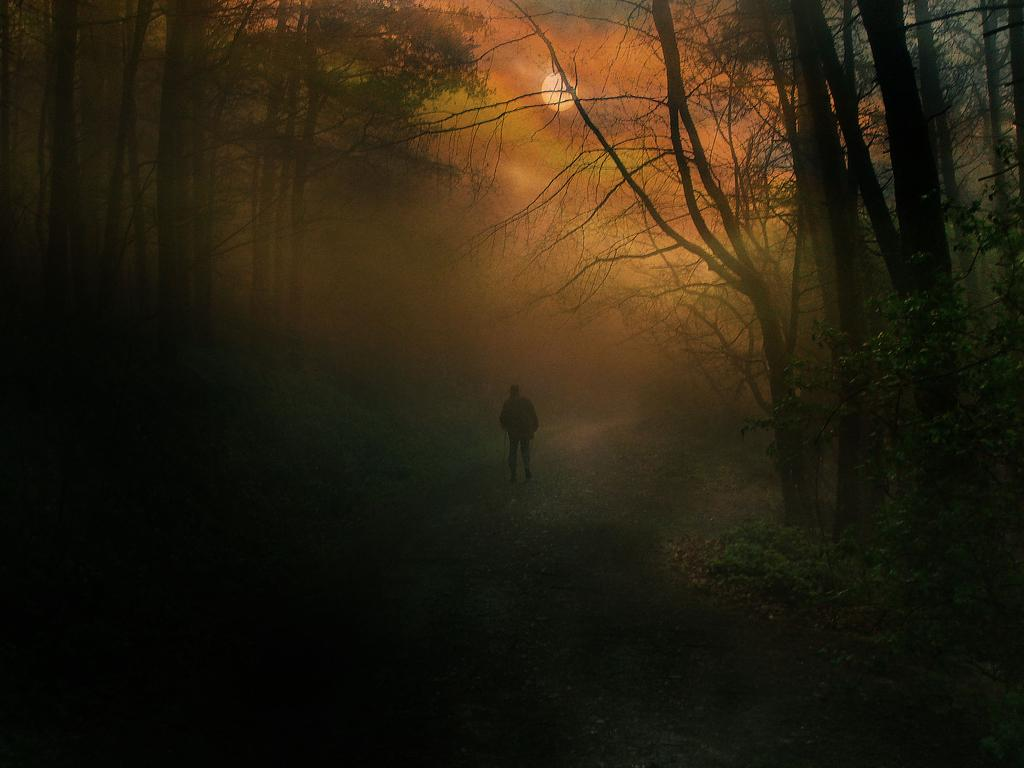What is the main subject of the image? There is a person in the image. What is the person holding in the image? The person is holding a stick. Where is the person standing in the image? The person is standing on the ground. What can be seen in the background of the image? There is a group of trees in the background of the image. What celestial body is visible in the sky in the image? The moon is visible in the sky in the image. What type of umbrella is the person using to shield themselves from the rain in the image? There is no umbrella present in the image, and it is not raining. What kind of haircut does the person have in the image? The image does not provide enough detail to determine the person's haircut. 